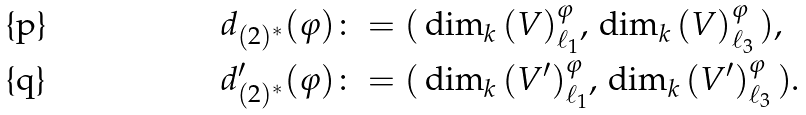<formula> <loc_0><loc_0><loc_500><loc_500>d _ { ( 2 ) ^ { * } } ( \varphi ) & \colon = ( \, \dim _ { k } \, ( V ) ^ { \varphi } _ { \ell _ { 1 } } , \, \dim _ { k } \, ( V ) ^ { \varphi } _ { \ell _ { 3 } } \, ) , \\ d ^ { \prime } _ { ( 2 ) ^ { * } } ( \varphi ) & \colon = ( \, \dim _ { k } \, ( V ^ { \prime } ) ^ { \varphi } _ { \ell _ { 1 } } , \, \dim _ { k } \, ( V ^ { \prime } ) ^ { \varphi } _ { \ell _ { 3 } } \, ) .</formula> 